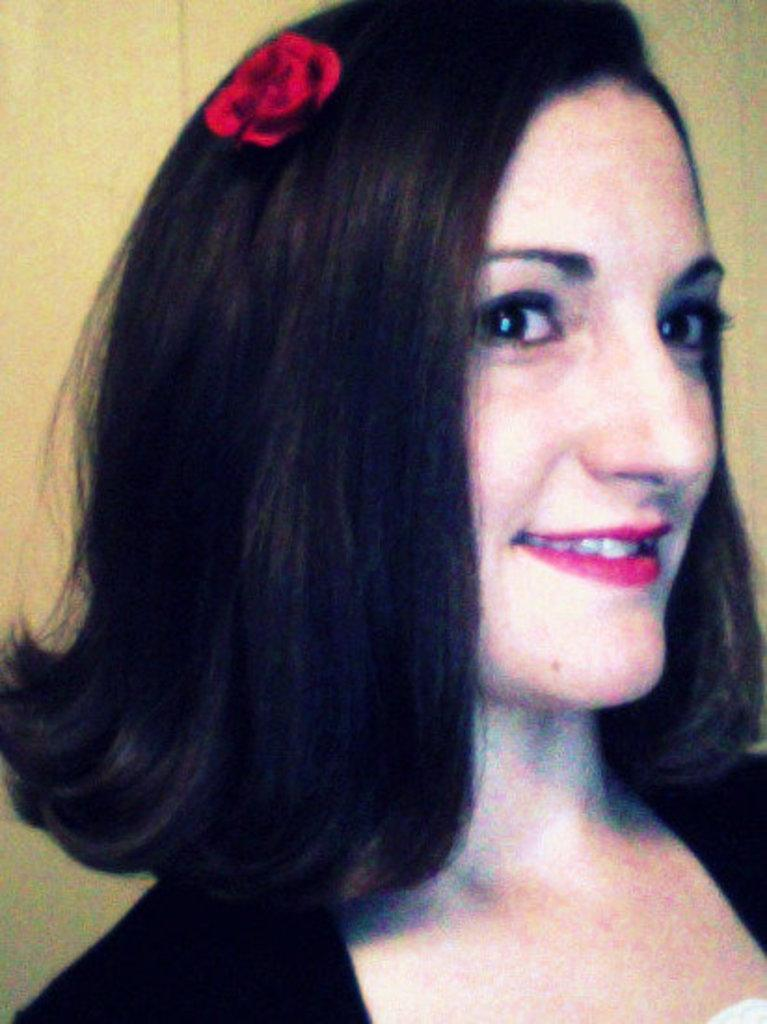What is the main subject in the foreground of the image? There is a woman in the foreground of the image. What is the woman wearing? The woman is wearing a black dress. What cosmetic detail can be observed on the woman's face? The woman has red lipstick. What accessory is the woman wearing in her hair? The woman has a red flower in her hair. What can be seen in the background of the image? There is a wall in the background of the image. What type of wound can be seen on the woman's arm in the image? There is no wound visible on the woman's arm in the image. What offer is the woman making to the viewer in the image? The image does not depict the woman making any offer to the viewer. 